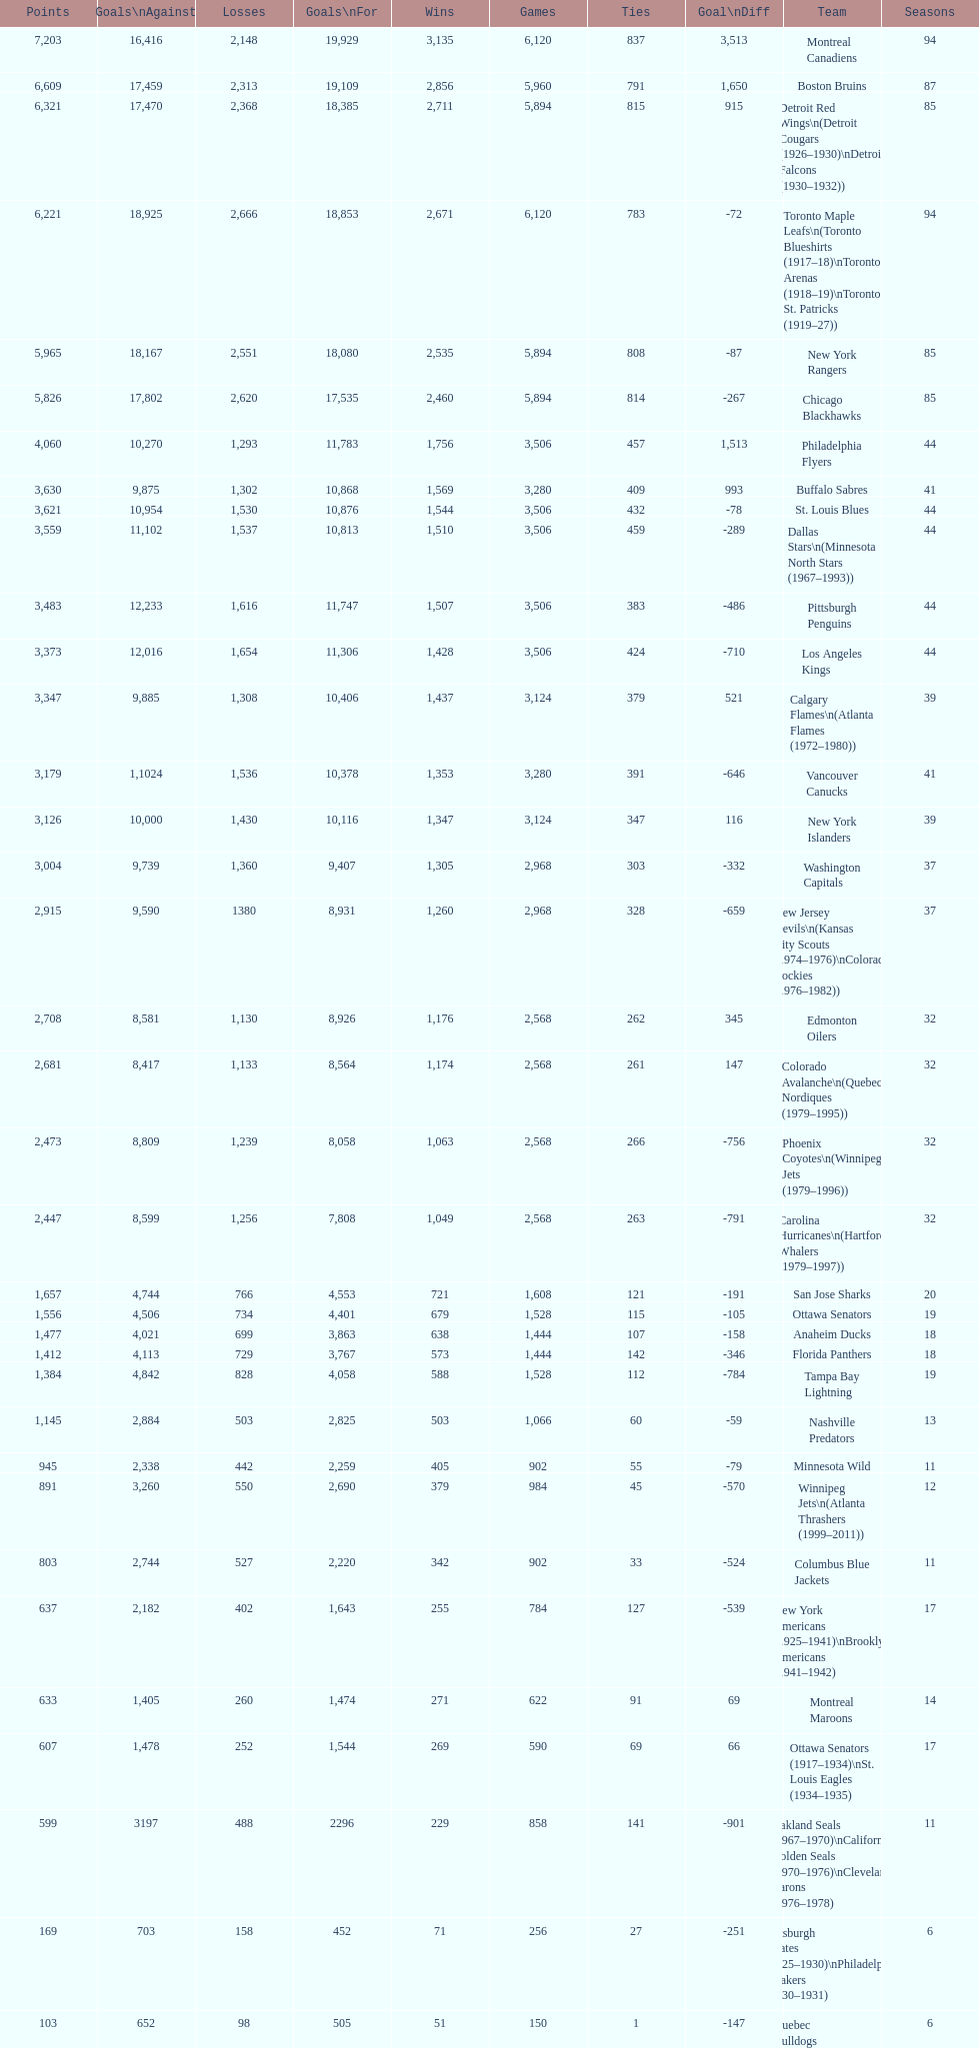What is the number of games that the vancouver canucks have won up to this point? 1,353. 